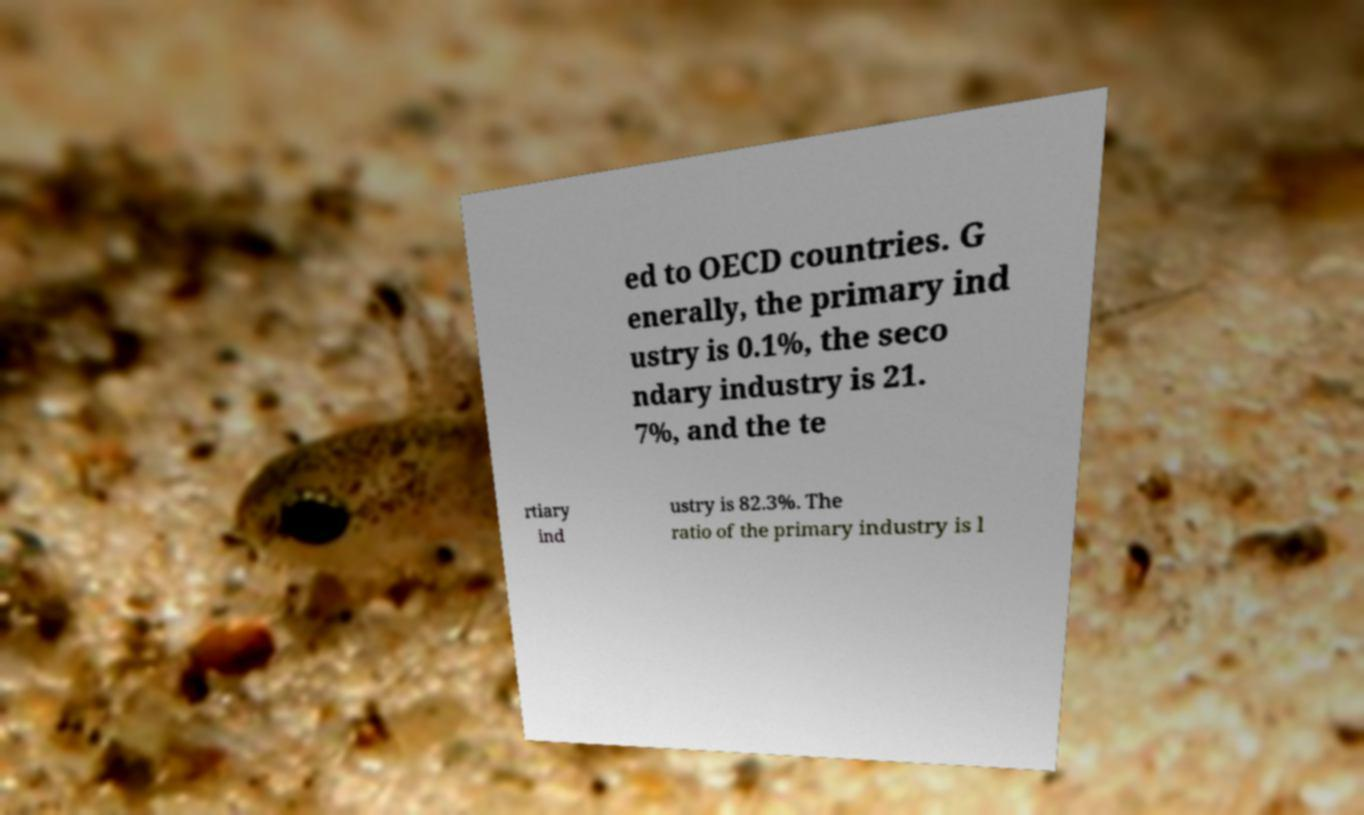Please read and relay the text visible in this image. What does it say? ed to OECD countries. G enerally, the primary ind ustry is 0.1%, the seco ndary industry is 21. 7%, and the te rtiary ind ustry is 82.3%. The ratio of the primary industry is l 